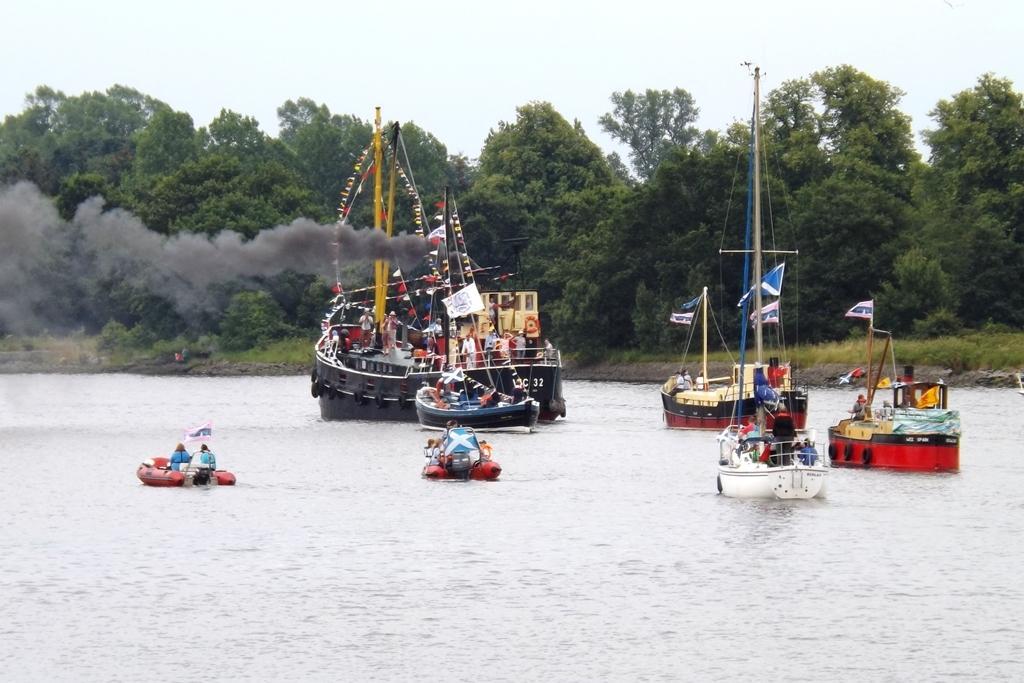Describe this image in one or two sentences. In this picture we can see some people, poles, flags and poles on the boats and the boats are on the water. Behind the boats there are trees and the sky. 